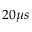<formula> <loc_0><loc_0><loc_500><loc_500>2 0 \mu s</formula> 